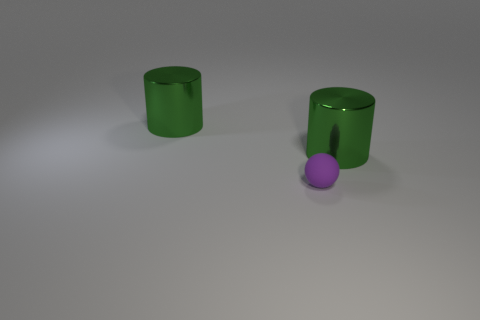How many green cylinders must be subtracted to get 1 green cylinders? 1 Add 2 big metallic objects. How many objects exist? 5 Subtract all cylinders. How many objects are left? 1 Add 1 matte things. How many matte things are left? 2 Add 2 purple balls. How many purple balls exist? 3 Subtract 0 cyan balls. How many objects are left? 3 Subtract all big green rubber things. Subtract all tiny purple things. How many objects are left? 2 